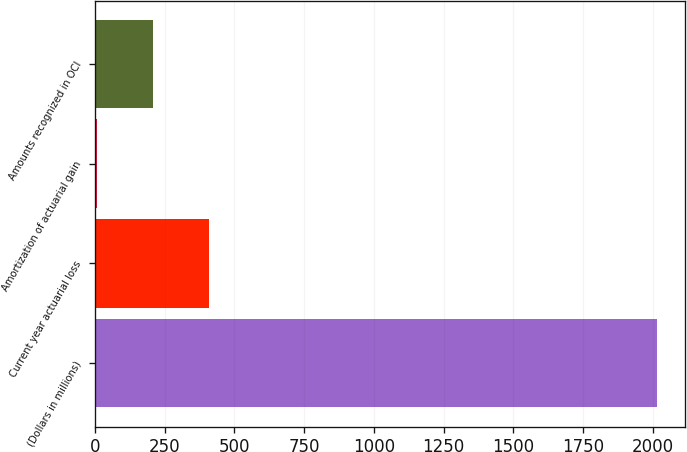Convert chart. <chart><loc_0><loc_0><loc_500><loc_500><bar_chart><fcel>(Dollars in millions)<fcel>Current year actuarial loss<fcel>Amortization of actuarial gain<fcel>Amounts recognized in OCI<nl><fcel>2016<fcel>408<fcel>6<fcel>207<nl></chart> 